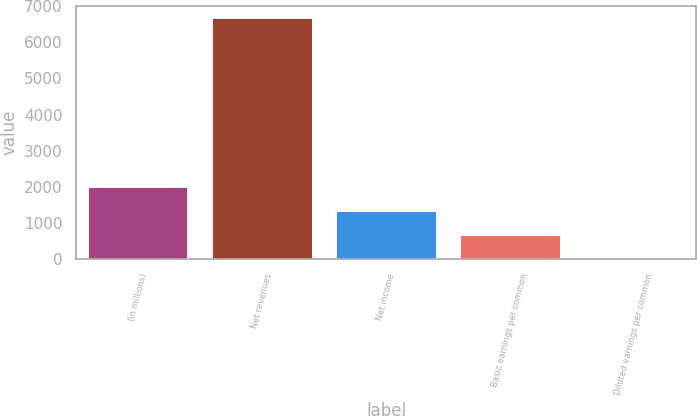<chart> <loc_0><loc_0><loc_500><loc_500><bar_chart><fcel>(in millions)<fcel>Net revenues<fcel>Net income<fcel>Basic earnings per common<fcel>Diluted earnings per common<nl><fcel>2015<fcel>6677<fcel>1336.09<fcel>668.47<fcel>0.85<nl></chart> 